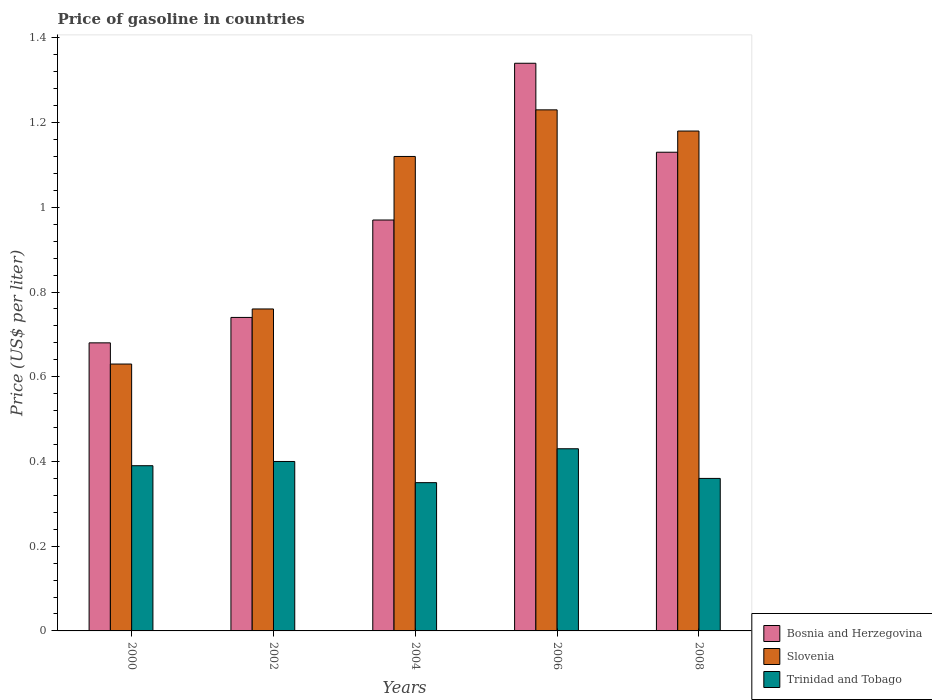How many different coloured bars are there?
Provide a succinct answer. 3. Are the number of bars per tick equal to the number of legend labels?
Your response must be concise. Yes. Are the number of bars on each tick of the X-axis equal?
Your answer should be compact. Yes. How many bars are there on the 3rd tick from the left?
Your response must be concise. 3. How many bars are there on the 2nd tick from the right?
Provide a short and direct response. 3. In how many cases, is the number of bars for a given year not equal to the number of legend labels?
Provide a short and direct response. 0. What is the price of gasoline in Slovenia in 2004?
Provide a succinct answer. 1.12. Across all years, what is the maximum price of gasoline in Trinidad and Tobago?
Make the answer very short. 0.43. Across all years, what is the minimum price of gasoline in Trinidad and Tobago?
Your answer should be compact. 0.35. What is the total price of gasoline in Bosnia and Herzegovina in the graph?
Offer a very short reply. 4.86. What is the difference between the price of gasoline in Slovenia in 2006 and that in 2008?
Offer a very short reply. 0.05. What is the difference between the price of gasoline in Slovenia in 2008 and the price of gasoline in Trinidad and Tobago in 2002?
Your response must be concise. 0.78. What is the average price of gasoline in Bosnia and Herzegovina per year?
Your answer should be very brief. 0.97. In the year 2004, what is the difference between the price of gasoline in Trinidad and Tobago and price of gasoline in Bosnia and Herzegovina?
Provide a short and direct response. -0.62. In how many years, is the price of gasoline in Trinidad and Tobago greater than 1.04 US$?
Offer a very short reply. 0. What is the ratio of the price of gasoline in Trinidad and Tobago in 2004 to that in 2008?
Ensure brevity in your answer.  0.97. Is the price of gasoline in Trinidad and Tobago in 2004 less than that in 2006?
Provide a short and direct response. Yes. Is the difference between the price of gasoline in Trinidad and Tobago in 2000 and 2008 greater than the difference between the price of gasoline in Bosnia and Herzegovina in 2000 and 2008?
Offer a terse response. Yes. What is the difference between the highest and the second highest price of gasoline in Slovenia?
Your response must be concise. 0.05. What is the difference between the highest and the lowest price of gasoline in Trinidad and Tobago?
Provide a short and direct response. 0.08. Is the sum of the price of gasoline in Bosnia and Herzegovina in 2004 and 2008 greater than the maximum price of gasoline in Slovenia across all years?
Provide a succinct answer. Yes. What does the 1st bar from the left in 2000 represents?
Your response must be concise. Bosnia and Herzegovina. What does the 2nd bar from the right in 2006 represents?
Provide a succinct answer. Slovenia. How many bars are there?
Provide a short and direct response. 15. Are all the bars in the graph horizontal?
Provide a short and direct response. No. What is the difference between two consecutive major ticks on the Y-axis?
Your answer should be very brief. 0.2. Does the graph contain any zero values?
Ensure brevity in your answer.  No. Does the graph contain grids?
Your answer should be very brief. No. How are the legend labels stacked?
Give a very brief answer. Vertical. What is the title of the graph?
Provide a succinct answer. Price of gasoline in countries. What is the label or title of the X-axis?
Provide a short and direct response. Years. What is the label or title of the Y-axis?
Your answer should be compact. Price (US$ per liter). What is the Price (US$ per liter) of Bosnia and Herzegovina in 2000?
Give a very brief answer. 0.68. What is the Price (US$ per liter) of Slovenia in 2000?
Your answer should be very brief. 0.63. What is the Price (US$ per liter) in Trinidad and Tobago in 2000?
Your answer should be very brief. 0.39. What is the Price (US$ per liter) in Bosnia and Herzegovina in 2002?
Provide a short and direct response. 0.74. What is the Price (US$ per liter) in Slovenia in 2002?
Offer a very short reply. 0.76. What is the Price (US$ per liter) in Slovenia in 2004?
Provide a short and direct response. 1.12. What is the Price (US$ per liter) in Bosnia and Herzegovina in 2006?
Give a very brief answer. 1.34. What is the Price (US$ per liter) of Slovenia in 2006?
Your response must be concise. 1.23. What is the Price (US$ per liter) of Trinidad and Tobago in 2006?
Your answer should be compact. 0.43. What is the Price (US$ per liter) of Bosnia and Herzegovina in 2008?
Provide a short and direct response. 1.13. What is the Price (US$ per liter) of Slovenia in 2008?
Give a very brief answer. 1.18. What is the Price (US$ per liter) of Trinidad and Tobago in 2008?
Give a very brief answer. 0.36. Across all years, what is the maximum Price (US$ per liter) in Bosnia and Herzegovina?
Provide a succinct answer. 1.34. Across all years, what is the maximum Price (US$ per liter) in Slovenia?
Make the answer very short. 1.23. Across all years, what is the maximum Price (US$ per liter) in Trinidad and Tobago?
Give a very brief answer. 0.43. Across all years, what is the minimum Price (US$ per liter) in Bosnia and Herzegovina?
Provide a succinct answer. 0.68. Across all years, what is the minimum Price (US$ per liter) in Slovenia?
Ensure brevity in your answer.  0.63. Across all years, what is the minimum Price (US$ per liter) of Trinidad and Tobago?
Offer a terse response. 0.35. What is the total Price (US$ per liter) of Bosnia and Herzegovina in the graph?
Offer a terse response. 4.86. What is the total Price (US$ per liter) in Slovenia in the graph?
Ensure brevity in your answer.  4.92. What is the total Price (US$ per liter) in Trinidad and Tobago in the graph?
Provide a short and direct response. 1.93. What is the difference between the Price (US$ per liter) of Bosnia and Herzegovina in 2000 and that in 2002?
Offer a terse response. -0.06. What is the difference between the Price (US$ per liter) in Slovenia in 2000 and that in 2002?
Offer a very short reply. -0.13. What is the difference between the Price (US$ per liter) of Trinidad and Tobago in 2000 and that in 2002?
Your answer should be very brief. -0.01. What is the difference between the Price (US$ per liter) of Bosnia and Herzegovina in 2000 and that in 2004?
Keep it short and to the point. -0.29. What is the difference between the Price (US$ per liter) in Slovenia in 2000 and that in 2004?
Give a very brief answer. -0.49. What is the difference between the Price (US$ per liter) in Trinidad and Tobago in 2000 and that in 2004?
Provide a short and direct response. 0.04. What is the difference between the Price (US$ per liter) of Bosnia and Herzegovina in 2000 and that in 2006?
Offer a terse response. -0.66. What is the difference between the Price (US$ per liter) in Trinidad and Tobago in 2000 and that in 2006?
Your answer should be compact. -0.04. What is the difference between the Price (US$ per liter) in Bosnia and Herzegovina in 2000 and that in 2008?
Your answer should be compact. -0.45. What is the difference between the Price (US$ per liter) of Slovenia in 2000 and that in 2008?
Provide a succinct answer. -0.55. What is the difference between the Price (US$ per liter) in Bosnia and Herzegovina in 2002 and that in 2004?
Your response must be concise. -0.23. What is the difference between the Price (US$ per liter) in Slovenia in 2002 and that in 2004?
Your response must be concise. -0.36. What is the difference between the Price (US$ per liter) of Bosnia and Herzegovina in 2002 and that in 2006?
Provide a succinct answer. -0.6. What is the difference between the Price (US$ per liter) in Slovenia in 2002 and that in 2006?
Provide a succinct answer. -0.47. What is the difference between the Price (US$ per liter) of Trinidad and Tobago in 2002 and that in 2006?
Your response must be concise. -0.03. What is the difference between the Price (US$ per liter) of Bosnia and Herzegovina in 2002 and that in 2008?
Your answer should be very brief. -0.39. What is the difference between the Price (US$ per liter) of Slovenia in 2002 and that in 2008?
Provide a short and direct response. -0.42. What is the difference between the Price (US$ per liter) of Bosnia and Herzegovina in 2004 and that in 2006?
Offer a very short reply. -0.37. What is the difference between the Price (US$ per liter) in Slovenia in 2004 and that in 2006?
Offer a very short reply. -0.11. What is the difference between the Price (US$ per liter) in Trinidad and Tobago in 2004 and that in 2006?
Ensure brevity in your answer.  -0.08. What is the difference between the Price (US$ per liter) in Bosnia and Herzegovina in 2004 and that in 2008?
Make the answer very short. -0.16. What is the difference between the Price (US$ per liter) of Slovenia in 2004 and that in 2008?
Give a very brief answer. -0.06. What is the difference between the Price (US$ per liter) of Trinidad and Tobago in 2004 and that in 2008?
Make the answer very short. -0.01. What is the difference between the Price (US$ per liter) of Bosnia and Herzegovina in 2006 and that in 2008?
Offer a very short reply. 0.21. What is the difference between the Price (US$ per liter) of Slovenia in 2006 and that in 2008?
Ensure brevity in your answer.  0.05. What is the difference between the Price (US$ per liter) in Trinidad and Tobago in 2006 and that in 2008?
Ensure brevity in your answer.  0.07. What is the difference between the Price (US$ per liter) in Bosnia and Herzegovina in 2000 and the Price (US$ per liter) in Slovenia in 2002?
Your answer should be compact. -0.08. What is the difference between the Price (US$ per liter) of Bosnia and Herzegovina in 2000 and the Price (US$ per liter) of Trinidad and Tobago in 2002?
Give a very brief answer. 0.28. What is the difference between the Price (US$ per liter) of Slovenia in 2000 and the Price (US$ per liter) of Trinidad and Tobago in 2002?
Keep it short and to the point. 0.23. What is the difference between the Price (US$ per liter) of Bosnia and Herzegovina in 2000 and the Price (US$ per liter) of Slovenia in 2004?
Provide a succinct answer. -0.44. What is the difference between the Price (US$ per liter) of Bosnia and Herzegovina in 2000 and the Price (US$ per liter) of Trinidad and Tobago in 2004?
Ensure brevity in your answer.  0.33. What is the difference between the Price (US$ per liter) in Slovenia in 2000 and the Price (US$ per liter) in Trinidad and Tobago in 2004?
Make the answer very short. 0.28. What is the difference between the Price (US$ per liter) in Bosnia and Herzegovina in 2000 and the Price (US$ per liter) in Slovenia in 2006?
Offer a terse response. -0.55. What is the difference between the Price (US$ per liter) in Slovenia in 2000 and the Price (US$ per liter) in Trinidad and Tobago in 2006?
Give a very brief answer. 0.2. What is the difference between the Price (US$ per liter) of Bosnia and Herzegovina in 2000 and the Price (US$ per liter) of Slovenia in 2008?
Your answer should be very brief. -0.5. What is the difference between the Price (US$ per liter) in Bosnia and Herzegovina in 2000 and the Price (US$ per liter) in Trinidad and Tobago in 2008?
Your answer should be very brief. 0.32. What is the difference between the Price (US$ per liter) in Slovenia in 2000 and the Price (US$ per liter) in Trinidad and Tobago in 2008?
Your answer should be very brief. 0.27. What is the difference between the Price (US$ per liter) in Bosnia and Herzegovina in 2002 and the Price (US$ per liter) in Slovenia in 2004?
Your answer should be compact. -0.38. What is the difference between the Price (US$ per liter) in Bosnia and Herzegovina in 2002 and the Price (US$ per liter) in Trinidad and Tobago in 2004?
Your response must be concise. 0.39. What is the difference between the Price (US$ per liter) of Slovenia in 2002 and the Price (US$ per liter) of Trinidad and Tobago in 2004?
Offer a very short reply. 0.41. What is the difference between the Price (US$ per liter) of Bosnia and Herzegovina in 2002 and the Price (US$ per liter) of Slovenia in 2006?
Your response must be concise. -0.49. What is the difference between the Price (US$ per liter) of Bosnia and Herzegovina in 2002 and the Price (US$ per liter) of Trinidad and Tobago in 2006?
Make the answer very short. 0.31. What is the difference between the Price (US$ per liter) of Slovenia in 2002 and the Price (US$ per liter) of Trinidad and Tobago in 2006?
Offer a very short reply. 0.33. What is the difference between the Price (US$ per liter) of Bosnia and Herzegovina in 2002 and the Price (US$ per liter) of Slovenia in 2008?
Give a very brief answer. -0.44. What is the difference between the Price (US$ per liter) of Bosnia and Herzegovina in 2002 and the Price (US$ per liter) of Trinidad and Tobago in 2008?
Your answer should be very brief. 0.38. What is the difference between the Price (US$ per liter) of Bosnia and Herzegovina in 2004 and the Price (US$ per liter) of Slovenia in 2006?
Your answer should be very brief. -0.26. What is the difference between the Price (US$ per liter) of Bosnia and Herzegovina in 2004 and the Price (US$ per liter) of Trinidad and Tobago in 2006?
Your response must be concise. 0.54. What is the difference between the Price (US$ per liter) of Slovenia in 2004 and the Price (US$ per liter) of Trinidad and Tobago in 2006?
Your answer should be compact. 0.69. What is the difference between the Price (US$ per liter) in Bosnia and Herzegovina in 2004 and the Price (US$ per liter) in Slovenia in 2008?
Give a very brief answer. -0.21. What is the difference between the Price (US$ per liter) of Bosnia and Herzegovina in 2004 and the Price (US$ per liter) of Trinidad and Tobago in 2008?
Your answer should be very brief. 0.61. What is the difference between the Price (US$ per liter) of Slovenia in 2004 and the Price (US$ per liter) of Trinidad and Tobago in 2008?
Your response must be concise. 0.76. What is the difference between the Price (US$ per liter) of Bosnia and Herzegovina in 2006 and the Price (US$ per liter) of Slovenia in 2008?
Ensure brevity in your answer.  0.16. What is the difference between the Price (US$ per liter) in Bosnia and Herzegovina in 2006 and the Price (US$ per liter) in Trinidad and Tobago in 2008?
Make the answer very short. 0.98. What is the difference between the Price (US$ per liter) of Slovenia in 2006 and the Price (US$ per liter) of Trinidad and Tobago in 2008?
Your response must be concise. 0.87. What is the average Price (US$ per liter) in Bosnia and Herzegovina per year?
Your answer should be very brief. 0.97. What is the average Price (US$ per liter) of Trinidad and Tobago per year?
Your response must be concise. 0.39. In the year 2000, what is the difference between the Price (US$ per liter) in Bosnia and Herzegovina and Price (US$ per liter) in Trinidad and Tobago?
Your response must be concise. 0.29. In the year 2000, what is the difference between the Price (US$ per liter) of Slovenia and Price (US$ per liter) of Trinidad and Tobago?
Provide a short and direct response. 0.24. In the year 2002, what is the difference between the Price (US$ per liter) of Bosnia and Herzegovina and Price (US$ per liter) of Slovenia?
Make the answer very short. -0.02. In the year 2002, what is the difference between the Price (US$ per liter) in Bosnia and Herzegovina and Price (US$ per liter) in Trinidad and Tobago?
Provide a succinct answer. 0.34. In the year 2002, what is the difference between the Price (US$ per liter) in Slovenia and Price (US$ per liter) in Trinidad and Tobago?
Your answer should be compact. 0.36. In the year 2004, what is the difference between the Price (US$ per liter) of Bosnia and Herzegovina and Price (US$ per liter) of Trinidad and Tobago?
Your answer should be very brief. 0.62. In the year 2004, what is the difference between the Price (US$ per liter) in Slovenia and Price (US$ per liter) in Trinidad and Tobago?
Provide a succinct answer. 0.77. In the year 2006, what is the difference between the Price (US$ per liter) of Bosnia and Herzegovina and Price (US$ per liter) of Slovenia?
Offer a very short reply. 0.11. In the year 2006, what is the difference between the Price (US$ per liter) of Bosnia and Herzegovina and Price (US$ per liter) of Trinidad and Tobago?
Keep it short and to the point. 0.91. In the year 2006, what is the difference between the Price (US$ per liter) in Slovenia and Price (US$ per liter) in Trinidad and Tobago?
Your response must be concise. 0.8. In the year 2008, what is the difference between the Price (US$ per liter) of Bosnia and Herzegovina and Price (US$ per liter) of Slovenia?
Give a very brief answer. -0.05. In the year 2008, what is the difference between the Price (US$ per liter) in Bosnia and Herzegovina and Price (US$ per liter) in Trinidad and Tobago?
Your answer should be very brief. 0.77. In the year 2008, what is the difference between the Price (US$ per liter) of Slovenia and Price (US$ per liter) of Trinidad and Tobago?
Keep it short and to the point. 0.82. What is the ratio of the Price (US$ per liter) in Bosnia and Herzegovina in 2000 to that in 2002?
Your response must be concise. 0.92. What is the ratio of the Price (US$ per liter) of Slovenia in 2000 to that in 2002?
Offer a very short reply. 0.83. What is the ratio of the Price (US$ per liter) of Trinidad and Tobago in 2000 to that in 2002?
Your answer should be very brief. 0.97. What is the ratio of the Price (US$ per liter) of Bosnia and Herzegovina in 2000 to that in 2004?
Your answer should be compact. 0.7. What is the ratio of the Price (US$ per liter) in Slovenia in 2000 to that in 2004?
Your response must be concise. 0.56. What is the ratio of the Price (US$ per liter) in Trinidad and Tobago in 2000 to that in 2004?
Offer a very short reply. 1.11. What is the ratio of the Price (US$ per liter) in Bosnia and Herzegovina in 2000 to that in 2006?
Give a very brief answer. 0.51. What is the ratio of the Price (US$ per liter) in Slovenia in 2000 to that in 2006?
Your response must be concise. 0.51. What is the ratio of the Price (US$ per liter) of Trinidad and Tobago in 2000 to that in 2006?
Your answer should be very brief. 0.91. What is the ratio of the Price (US$ per liter) in Bosnia and Herzegovina in 2000 to that in 2008?
Make the answer very short. 0.6. What is the ratio of the Price (US$ per liter) of Slovenia in 2000 to that in 2008?
Your answer should be very brief. 0.53. What is the ratio of the Price (US$ per liter) in Trinidad and Tobago in 2000 to that in 2008?
Offer a terse response. 1.08. What is the ratio of the Price (US$ per liter) of Bosnia and Herzegovina in 2002 to that in 2004?
Your response must be concise. 0.76. What is the ratio of the Price (US$ per liter) of Slovenia in 2002 to that in 2004?
Keep it short and to the point. 0.68. What is the ratio of the Price (US$ per liter) in Bosnia and Herzegovina in 2002 to that in 2006?
Your answer should be very brief. 0.55. What is the ratio of the Price (US$ per liter) of Slovenia in 2002 to that in 2006?
Your answer should be compact. 0.62. What is the ratio of the Price (US$ per liter) of Trinidad and Tobago in 2002 to that in 2006?
Provide a short and direct response. 0.93. What is the ratio of the Price (US$ per liter) of Bosnia and Herzegovina in 2002 to that in 2008?
Provide a short and direct response. 0.65. What is the ratio of the Price (US$ per liter) of Slovenia in 2002 to that in 2008?
Your response must be concise. 0.64. What is the ratio of the Price (US$ per liter) of Bosnia and Herzegovina in 2004 to that in 2006?
Provide a succinct answer. 0.72. What is the ratio of the Price (US$ per liter) in Slovenia in 2004 to that in 2006?
Keep it short and to the point. 0.91. What is the ratio of the Price (US$ per liter) in Trinidad and Tobago in 2004 to that in 2006?
Offer a very short reply. 0.81. What is the ratio of the Price (US$ per liter) of Bosnia and Herzegovina in 2004 to that in 2008?
Your answer should be very brief. 0.86. What is the ratio of the Price (US$ per liter) of Slovenia in 2004 to that in 2008?
Your answer should be compact. 0.95. What is the ratio of the Price (US$ per liter) in Trinidad and Tobago in 2004 to that in 2008?
Ensure brevity in your answer.  0.97. What is the ratio of the Price (US$ per liter) of Bosnia and Herzegovina in 2006 to that in 2008?
Offer a very short reply. 1.19. What is the ratio of the Price (US$ per liter) in Slovenia in 2006 to that in 2008?
Make the answer very short. 1.04. What is the ratio of the Price (US$ per liter) of Trinidad and Tobago in 2006 to that in 2008?
Offer a very short reply. 1.19. What is the difference between the highest and the second highest Price (US$ per liter) in Bosnia and Herzegovina?
Offer a very short reply. 0.21. What is the difference between the highest and the second highest Price (US$ per liter) of Trinidad and Tobago?
Make the answer very short. 0.03. What is the difference between the highest and the lowest Price (US$ per liter) in Bosnia and Herzegovina?
Your answer should be compact. 0.66. What is the difference between the highest and the lowest Price (US$ per liter) of Slovenia?
Offer a very short reply. 0.6. 